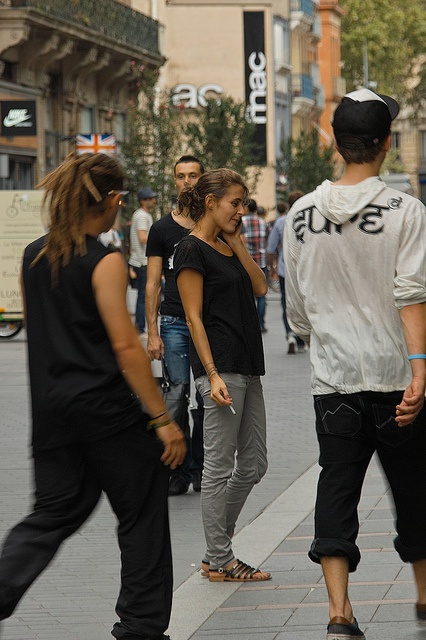Describe the objects in this image and their specific colors. I can see people in gray, black, maroon, and brown tones, people in gray, darkgray, black, and lightgray tones, people in gray, black, maroon, and brown tones, people in gray, black, and maroon tones, and people in gray, black, and darkgray tones in this image. 